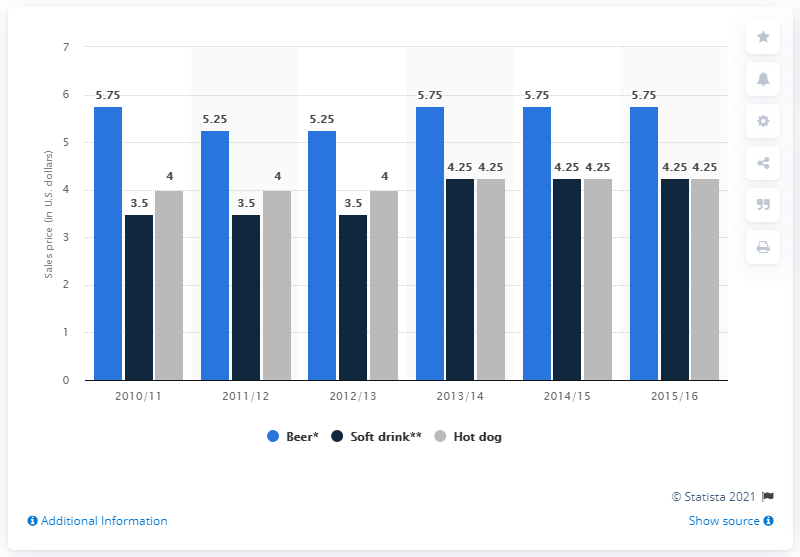Mention a couple of crucial points in this snapshot. In the 2012/2013 season, the cost of a 16 ounce beer was approximately 5.25 dollars. 